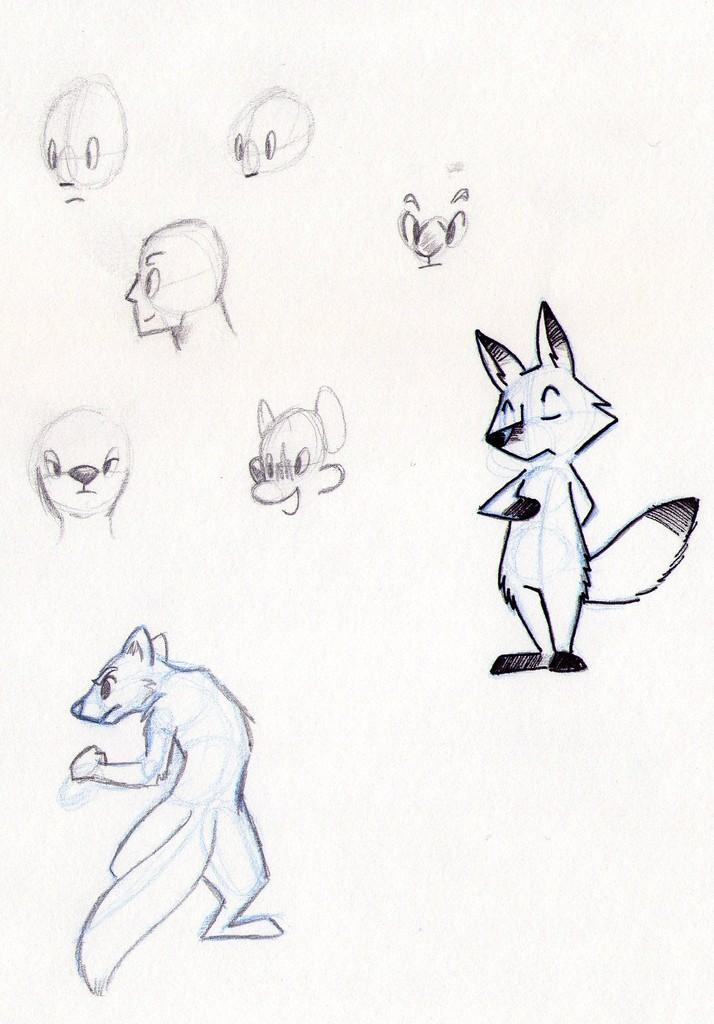What is the primary object in the image? There is a white color paper in the image. What can be seen on the paper? There are drawings of animals on the paper. How many rings are visible on the animals in the image? There are no rings visible on the animals in the image, as the provided facts only mention drawings of animals on the paper. 